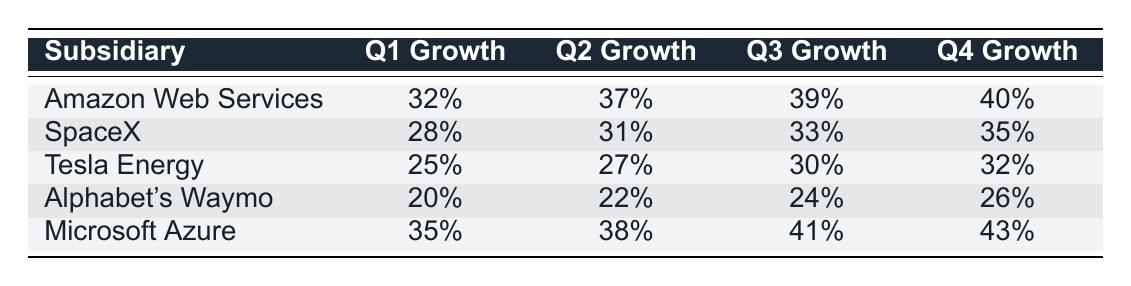What is the Q4 Growth percentage for Microsoft Azure? The table shows that the Q4 Growth percentage for Microsoft Azure is 43%.
Answer: 43% Which subsidiary experienced the highest Q3 Growth? Looking down the Q3 Growth column, we see that Microsoft Azure has the highest Q3 Growth at 41%.
Answer: 41% What is the average Q1 Growth across all subsidiaries? To find the average Q1 Growth, we add the percentages (32 + 28 + 25 + 20 + 35) = 140, and then divide by 5, yielding an average of 28%.
Answer: 28% Is the Q2 Growth for Tesla Energy greater than the Q1 Growth for SpaceX? No, Tesla Energy's Q2 Growth is 27%, and SpaceX's Q1 Growth is 28%, making 27% less than 28%.
Answer: No What is the total Q3 Growth percentage for all subsidiaries combined? The total Q3 Growth is calculated by adding the percentages (39 + 33 + 30 + 24 + 41) = 207%. Therefore, the total Q3 Growth for all subsidiaries is 207%.
Answer: 207% Which subsidiary shows consistent growth each quarter from Q1 to Q4? Upon examining the Q1 to Q4 Growth for each subsidiary, Microsoft Azure consistently increases each quarter: 35%, 38%, 41%, and 43%.
Answer: Microsoft Azure What is the difference in Q4 Growth between Amazon Web Services and Alphabet's Waymo? Amazon Web Services has a Q4 Growth of 40%, while Alphabet's Waymo has a Q4 Growth of 26%. The difference is 40% - 26% = 14%.
Answer: 14% Which subsidiary showed the smallest growth in Q1? Looking at the Q1 Growth percentages, Tesla Energy shows the smallest growth at 25%.
Answer: 25% Was Alphabet's Waymo's growth in Q3 lower than SpaceX's growth in Q2? Yes, Alphabet's Waymo had a Q3 Growth of 24%, which is lower than SpaceX's Q2 Growth at 31%.
Answer: Yes 